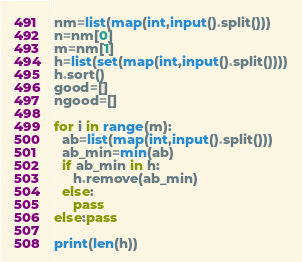<code> <loc_0><loc_0><loc_500><loc_500><_Python_>nm=list(map(int,input().split()))
n=nm[0]
m=nm[1]
h=list(set(map(int,input().split())))
h.sort()
good=[]
ngood=[]

for i in range(m):
  ab=list(map(int,input().split()))
  ab_min=min(ab)  
  if ab_min in h:
     h.remove(ab_min)
  else:
     pass    
else:pass

print(len(h))</code> 